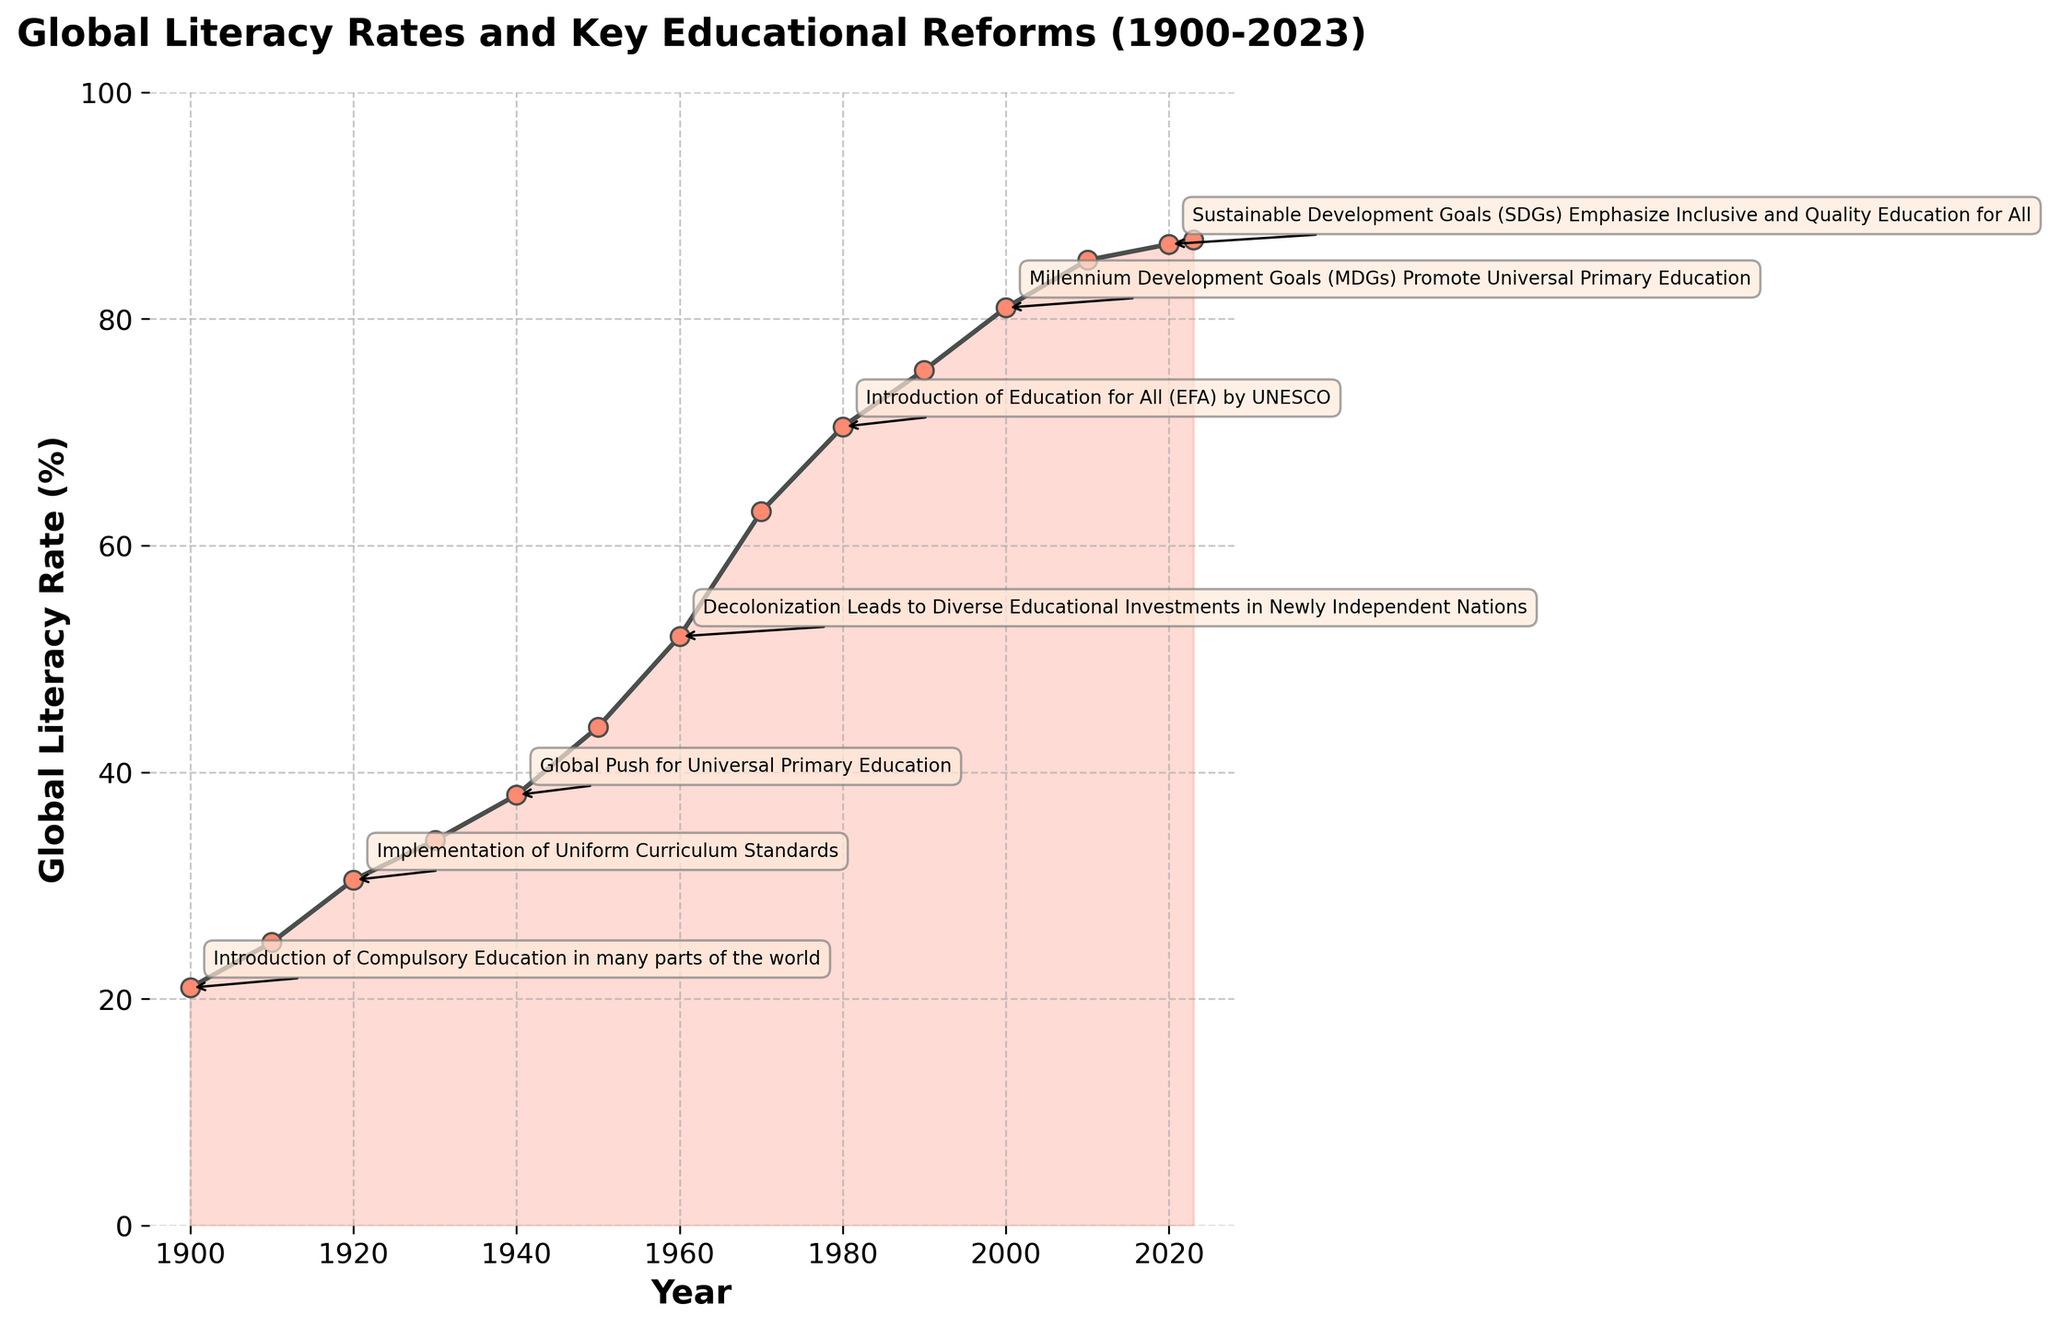What is the title of the figure? The title of a figure is usually located at the top, often in larger and bold text. We can find the title by looking for this prominent text at the top of the figure.
Answer: Global Literacy Rates and Key Educational Reforms (1900-2023) What year was the global literacy rate first documented to be above 50%? To answer this question, we need to find the year on the x-axis when the y-axis value first exceeds 50%. We observe that this happened in the year 1960.
Answer: 1960 Between which years did the most significant increase in global literacy rates occur? To determine this, we need to identify the steepest segment of the plot. By examining the slope of each segment between points, the most significant increase occurs between 1960 and 1970.
Answer: 1960-1970 How did the global literacy rate change from 2000 to 2010? We examine the values on the y-axis for the years 2000 and 2010. In 2000, the rate was 81.0%, and in 2010, it increased to 85.2%. The change is calculated as 85.2% - 81.0%.
Answer: Increased by 4.2% Which educational reform coincides with the year 1950? Look for the annotation on the figure near the point corresponding to the year 1950, which mentions the establishment of UNESCO to promote international literacy efforts.
Answer: UNESCO Founded to Promote International Literacy Efforts What was the global literacy rate in 1940, and what reform happened that year? To find this information, we look at the y-axis value corresponding to the year 1940 and the associated annotation. The literacy rate was 38.0%, with the global push for universal primary education happening that year.
Answer: 38.0%, Global Push for Universal Primary Education Which decade saw a more significant percentage increase in literacy rates, 1930-1940 or 1940-1950? Calculate the percentage increase for both decades. From 1930 to 1940: (38.0 - 34.0) / 34.0 * 100 ≈ 11.76%. From 1940 to 1950: (44.0 - 38.0) / 38.0 * 100 ≈ 15.79%. The second decade had a more significant increase.
Answer: 1940-1950 What was the global literacy rate in 2023, and what educational focus is mentioned for this year? Check the y-axis value and the annotation for the year 2023. The literacy rate is 87.0%, with a focus on early childhood education and lifelong learning.
Answer: 87.0%, Focus on Early Childhood Education and Lifelong Learning Which reform is associated with the smallest increase in literacy rate over a decade, and what was the rate change during that period? Identify key reforms and calculate the increase in literacy rates over corresponding decades. The smallest increase associated with a reform is between 2010 (85.2%) and 2020 (86.6%) with a 1.4% increase, during the period of the Sustainable Development Goals (SDGs).
Answer: Sustainable Development Goals (SDGs), Increase by 1.4% 